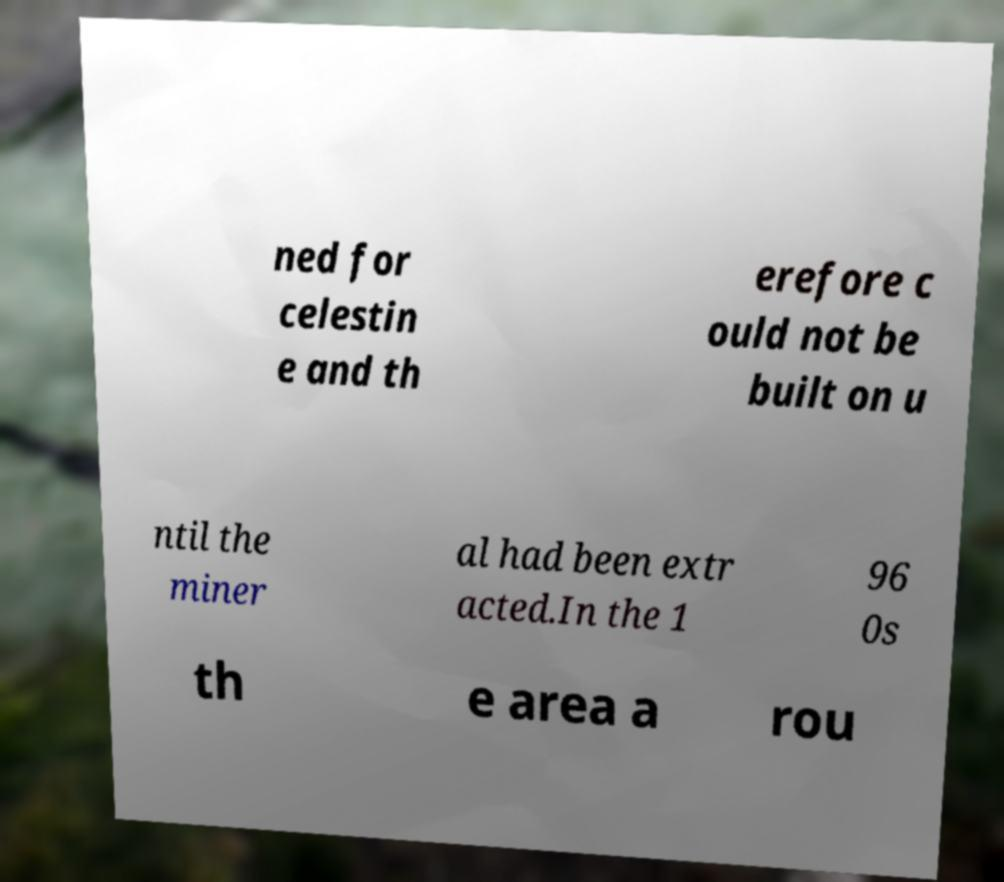Please read and relay the text visible in this image. What does it say? ned for celestin e and th erefore c ould not be built on u ntil the miner al had been extr acted.In the 1 96 0s th e area a rou 